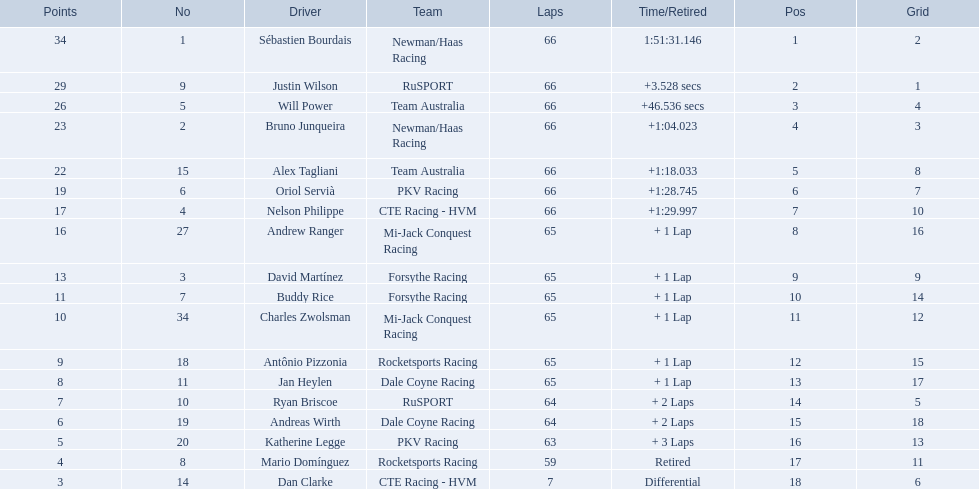What are the drivers numbers? 1, 9, 5, 2, 15, 6, 4, 27, 3, 7, 34, 18, 11, 10, 19, 20, 8, 14. Are there any who's number matches his position? Sébastien Bourdais, Oriol Servià. Of those two who has the highest position? Sébastien Bourdais. 